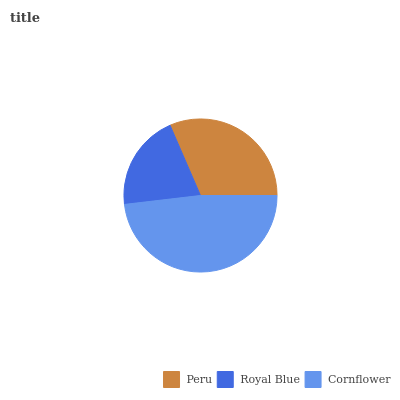Is Royal Blue the minimum?
Answer yes or no. Yes. Is Cornflower the maximum?
Answer yes or no. Yes. Is Cornflower the minimum?
Answer yes or no. No. Is Royal Blue the maximum?
Answer yes or no. No. Is Cornflower greater than Royal Blue?
Answer yes or no. Yes. Is Royal Blue less than Cornflower?
Answer yes or no. Yes. Is Royal Blue greater than Cornflower?
Answer yes or no. No. Is Cornflower less than Royal Blue?
Answer yes or no. No. Is Peru the high median?
Answer yes or no. Yes. Is Peru the low median?
Answer yes or no. Yes. Is Cornflower the high median?
Answer yes or no. No. Is Cornflower the low median?
Answer yes or no. No. 